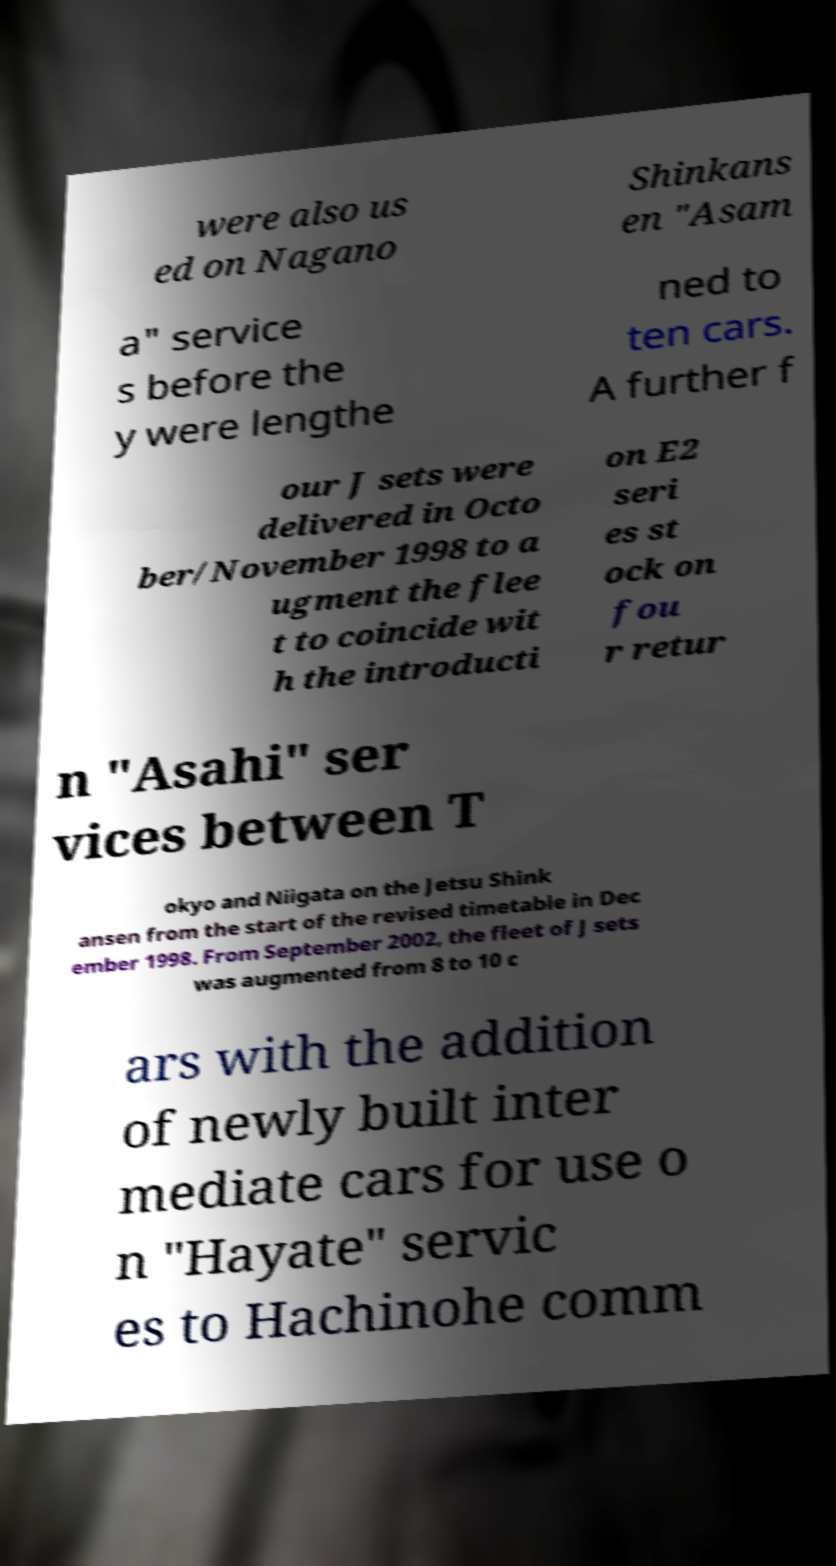Could you extract and type out the text from this image? were also us ed on Nagano Shinkans en "Asam a" service s before the y were lengthe ned to ten cars. A further f our J sets were delivered in Octo ber/November 1998 to a ugment the flee t to coincide wit h the introducti on E2 seri es st ock on fou r retur n "Asahi" ser vices between T okyo and Niigata on the Jetsu Shink ansen from the start of the revised timetable in Dec ember 1998. From September 2002, the fleet of J sets was augmented from 8 to 10 c ars with the addition of newly built inter mediate cars for use o n "Hayate" servic es to Hachinohe comm 